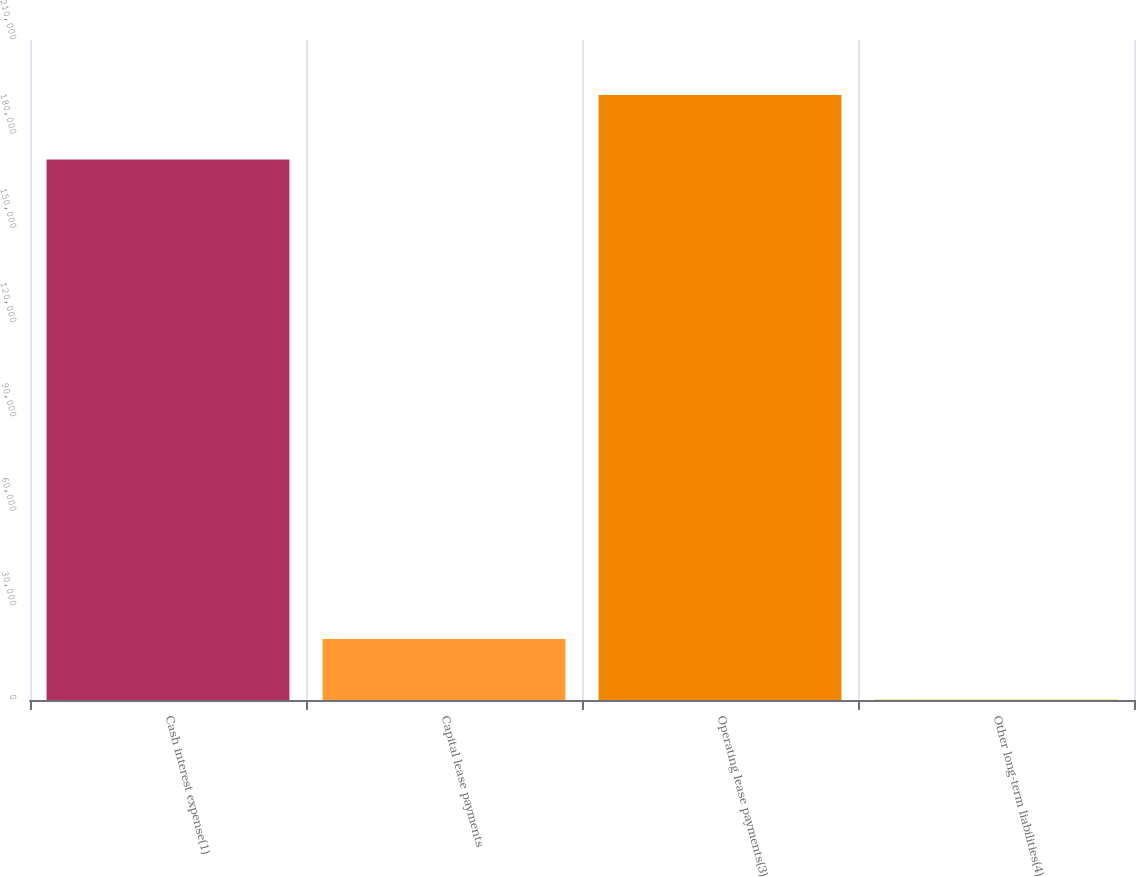Convert chart to OTSL. <chart><loc_0><loc_0><loc_500><loc_500><bar_chart><fcel>Cash interest expense(1)<fcel>Capital lease payments<fcel>Operating lease payments(3)<fcel>Other long-term liabilities(4)<nl><fcel>172000<fcel>19407.1<fcel>192487<fcel>176<nl></chart> 